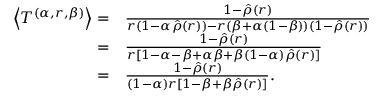Convert formula to latex. <formula><loc_0><loc_0><loc_500><loc_500>\begin{array} { r l } { \left \langle T ^ { ( \alpha , r , \beta ) } \right \rangle = } & { \frac { 1 - \hat { \rho } ( r ) } { r ( 1 - \alpha \hat { \rho } ( r ) ) - r ( \beta + \alpha ( 1 - \beta ) ) ( 1 - \hat { \rho } ( r ) ) } } \\ { = } & { \frac { 1 - \hat { \rho } ( r ) } { r [ 1 - \alpha - \beta + \alpha \beta + \beta ( 1 - \alpha ) \hat { \rho } ( r ) ] } } \\ { = } & { \frac { 1 - \hat { \rho } ( r ) } { ( 1 - \alpha ) r [ 1 - \beta + \beta \hat { \rho } ( r ) ] } . } \end{array}</formula> 